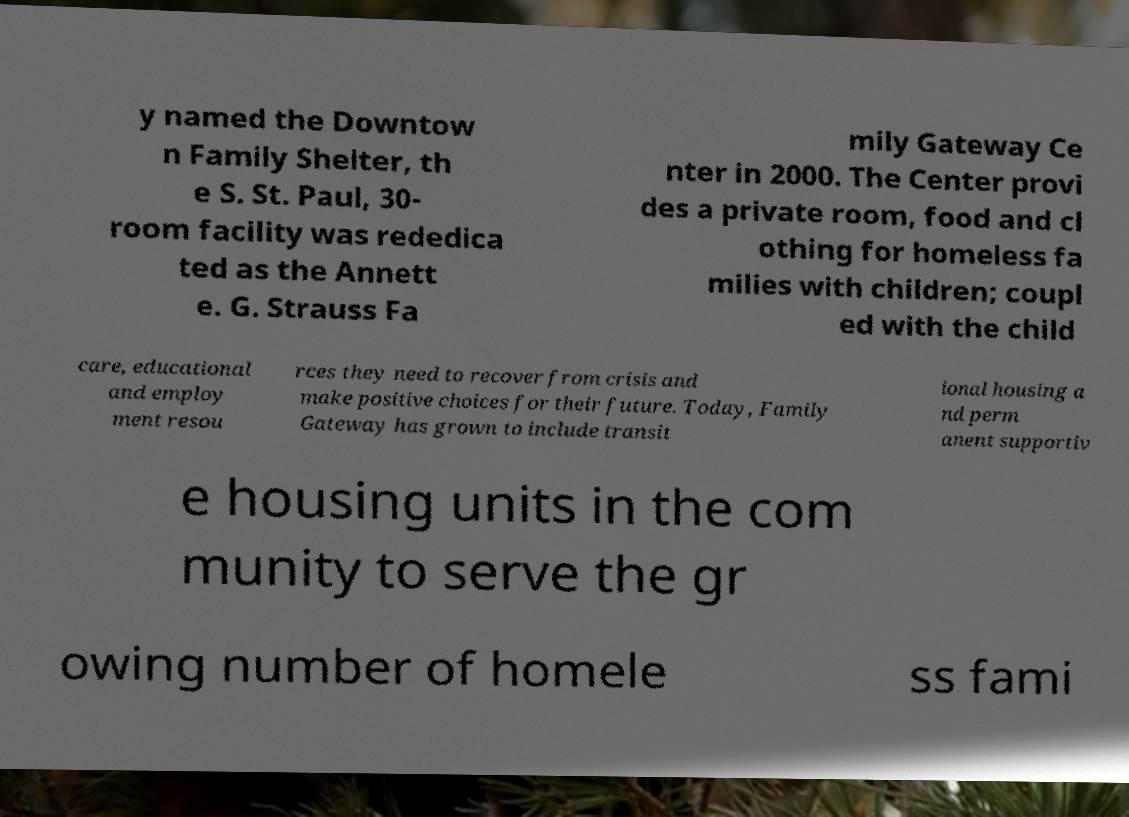Please identify and transcribe the text found in this image. y named the Downtow n Family Shelter, th e S. St. Paul, 30- room facility was rededica ted as the Annett e. G. Strauss Fa mily Gateway Ce nter in 2000. The Center provi des a private room, food and cl othing for homeless fa milies with children; coupl ed with the child care, educational and employ ment resou rces they need to recover from crisis and make positive choices for their future. Today, Family Gateway has grown to include transit ional housing a nd perm anent supportiv e housing units in the com munity to serve the gr owing number of homele ss fami 